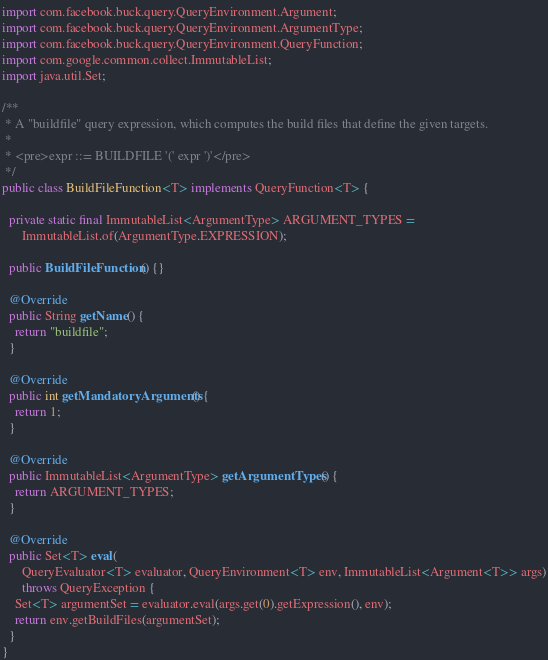Convert code to text. <code><loc_0><loc_0><loc_500><loc_500><_Java_>
import com.facebook.buck.query.QueryEnvironment.Argument;
import com.facebook.buck.query.QueryEnvironment.ArgumentType;
import com.facebook.buck.query.QueryEnvironment.QueryFunction;
import com.google.common.collect.ImmutableList;
import java.util.Set;

/**
 * A "buildfile" query expression, which computes the build files that define the given targets.
 *
 * <pre>expr ::= BUILDFILE '(' expr ')'</pre>
 */
public class BuildFileFunction<T> implements QueryFunction<T> {

  private static final ImmutableList<ArgumentType> ARGUMENT_TYPES =
      ImmutableList.of(ArgumentType.EXPRESSION);

  public BuildFileFunction() {}

  @Override
  public String getName() {
    return "buildfile";
  }

  @Override
  public int getMandatoryArguments() {
    return 1;
  }

  @Override
  public ImmutableList<ArgumentType> getArgumentTypes() {
    return ARGUMENT_TYPES;
  }

  @Override
  public Set<T> eval(
      QueryEvaluator<T> evaluator, QueryEnvironment<T> env, ImmutableList<Argument<T>> args)
      throws QueryException {
    Set<T> argumentSet = evaluator.eval(args.get(0).getExpression(), env);
    return env.getBuildFiles(argumentSet);
  }
}
</code> 